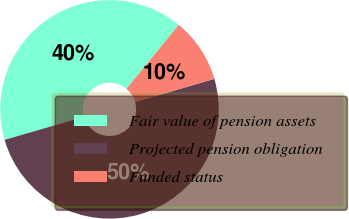Convert chart. <chart><loc_0><loc_0><loc_500><loc_500><pie_chart><fcel>Fair value of pension assets<fcel>Projected pension obligation<fcel>Funded status<nl><fcel>40.44%<fcel>50.0%<fcel>9.56%<nl></chart> 